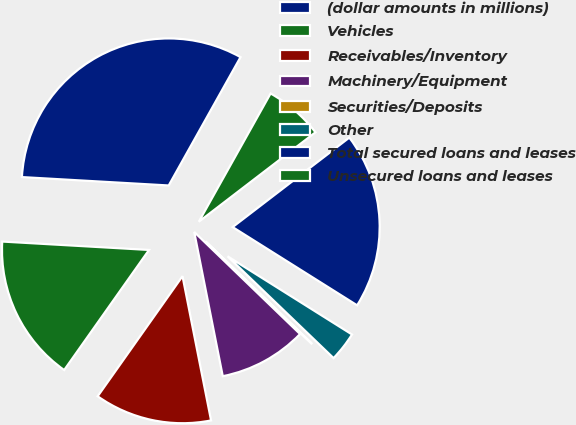Convert chart to OTSL. <chart><loc_0><loc_0><loc_500><loc_500><pie_chart><fcel>(dollar amounts in millions)<fcel>Vehicles<fcel>Receivables/Inventory<fcel>Machinery/Equipment<fcel>Securities/Deposits<fcel>Other<fcel>Total secured loans and leases<fcel>Unsecured loans and leases<nl><fcel>32.21%<fcel>16.12%<fcel>12.9%<fcel>9.68%<fcel>0.03%<fcel>3.25%<fcel>19.34%<fcel>6.47%<nl></chart> 